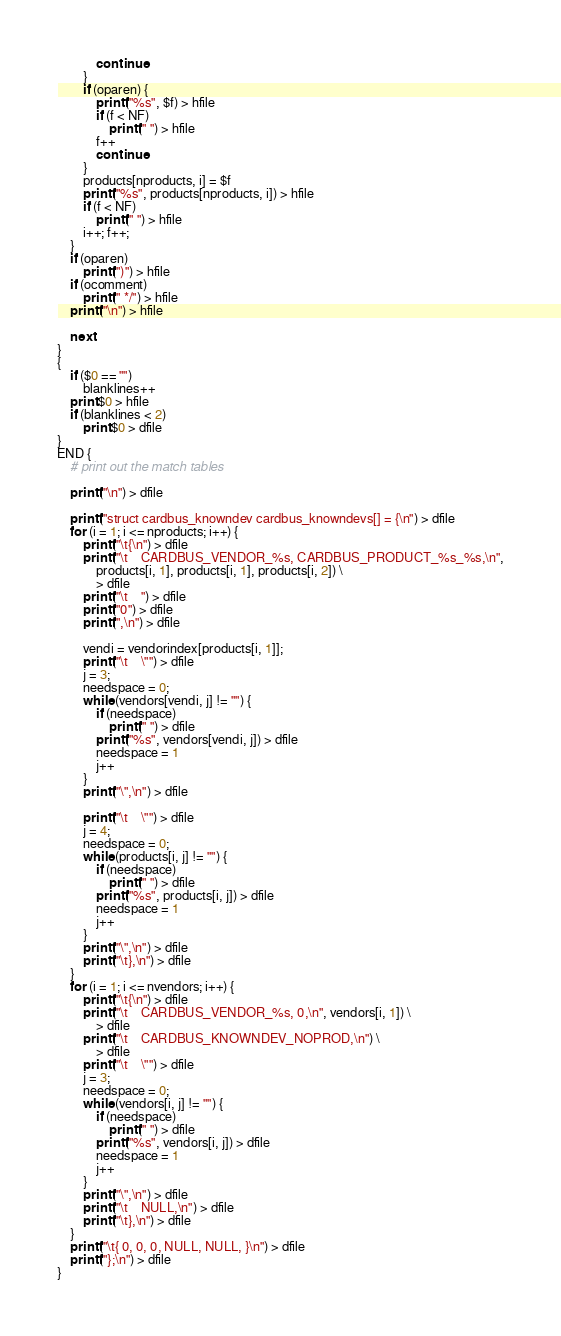Convert code to text. <code><loc_0><loc_0><loc_500><loc_500><_Awk_>			continue
		}
		if (oparen) {
			printf("%s", $f) > hfile
			if (f < NF)
				printf(" ") > hfile
			f++
			continue
		}
		products[nproducts, i] = $f
		printf("%s", products[nproducts, i]) > hfile
		if (f < NF)
			printf(" ") > hfile
		i++; f++;
	}
	if (oparen)
		printf(")") > hfile
	if (ocomment)
		printf(" */") > hfile
	printf("\n") > hfile

	next
}
{
	if ($0 == "")
		blanklines++
	print $0 > hfile
	if (blanklines < 2)
		print $0 > dfile
}
END {
	# print out the match tables

	printf("\n") > dfile

	printf("struct cardbus_knowndev cardbus_knowndevs[] = {\n") > dfile
	for (i = 1; i <= nproducts; i++) {
		printf("\t{\n") > dfile
		printf("\t    CARDBUS_VENDOR_%s, CARDBUS_PRODUCT_%s_%s,\n",
		    products[i, 1], products[i, 1], products[i, 2]) \
		    > dfile
		printf("\t    ") > dfile
		printf("0") > dfile
		printf(",\n") > dfile

		vendi = vendorindex[products[i, 1]];
		printf("\t    \"") > dfile
		j = 3;
		needspace = 0;
		while (vendors[vendi, j] != "") {
			if (needspace)
				printf(" ") > dfile
			printf("%s", vendors[vendi, j]) > dfile
			needspace = 1
			j++
		}
		printf("\",\n") > dfile

		printf("\t    \"") > dfile
		j = 4;
		needspace = 0;
		while (products[i, j] != "") {
			if (needspace)
				printf(" ") > dfile
			printf("%s", products[i, j]) > dfile
			needspace = 1
			j++
		}
		printf("\",\n") > dfile
		printf("\t},\n") > dfile
	}
	for (i = 1; i <= nvendors; i++) {
		printf("\t{\n") > dfile
		printf("\t    CARDBUS_VENDOR_%s, 0,\n", vendors[i, 1]) \
		    > dfile
		printf("\t    CARDBUS_KNOWNDEV_NOPROD,\n") \
		    > dfile
		printf("\t    \"") > dfile
		j = 3;
		needspace = 0;
		while (vendors[i, j] != "") {
			if (needspace)
				printf(" ") > dfile
			printf("%s", vendors[i, j]) > dfile
			needspace = 1
			j++
		}
		printf("\",\n") > dfile
		printf("\t    NULL,\n") > dfile
		printf("\t},\n") > dfile
	}
	printf("\t{ 0, 0, 0, NULL, NULL, }\n") > dfile
	printf("};\n") > dfile
}
</code> 